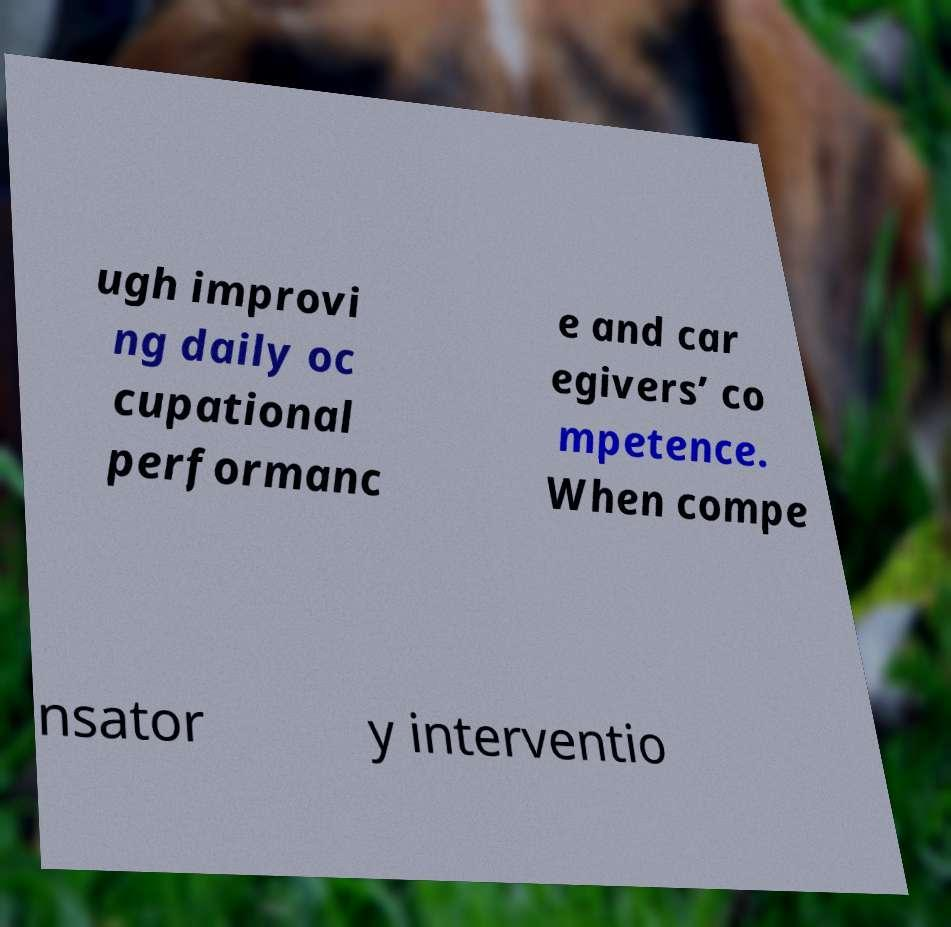Can you read and provide the text displayed in the image?This photo seems to have some interesting text. Can you extract and type it out for me? ugh improvi ng daily oc cupational performanc e and car egivers’ co mpetence. When compe nsator y interventio 